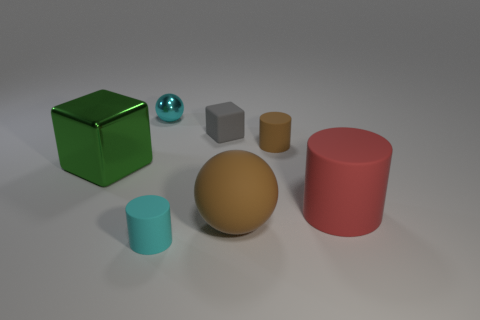The cube that is right of the tiny cylinder in front of the big red object that is behind the cyan matte cylinder is made of what material?
Provide a succinct answer. Rubber. What is the shape of the small brown object that is made of the same material as the gray thing?
Keep it short and to the point. Cylinder. There is a cyan thing that is behind the tiny cyan matte thing; are there any small metallic balls in front of it?
Keep it short and to the point. No. The metallic cube is what size?
Ensure brevity in your answer.  Large. What number of objects are either gray blocks or large metallic cubes?
Your response must be concise. 2. Does the sphere that is in front of the tiny gray matte thing have the same material as the ball that is behind the big block?
Your answer should be very brief. No. What color is the other large object that is made of the same material as the large red object?
Offer a terse response. Brown. What number of brown cylinders are the same size as the green thing?
Ensure brevity in your answer.  0. What number of other objects are there of the same color as the small metal object?
Offer a terse response. 1. There is a metallic object that is on the left side of the tiny metallic ball; does it have the same shape as the small gray thing that is to the left of the large brown thing?
Your response must be concise. Yes. 